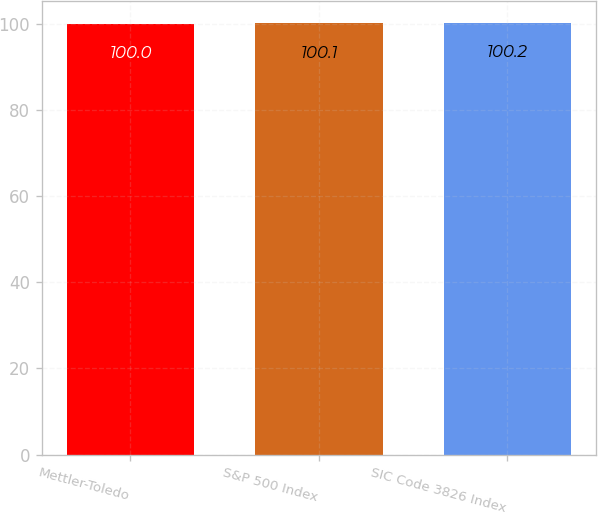<chart> <loc_0><loc_0><loc_500><loc_500><bar_chart><fcel>Mettler-Toledo<fcel>S&P 500 Index<fcel>SIC Code 3826 Index<nl><fcel>100<fcel>100.1<fcel>100.2<nl></chart> 